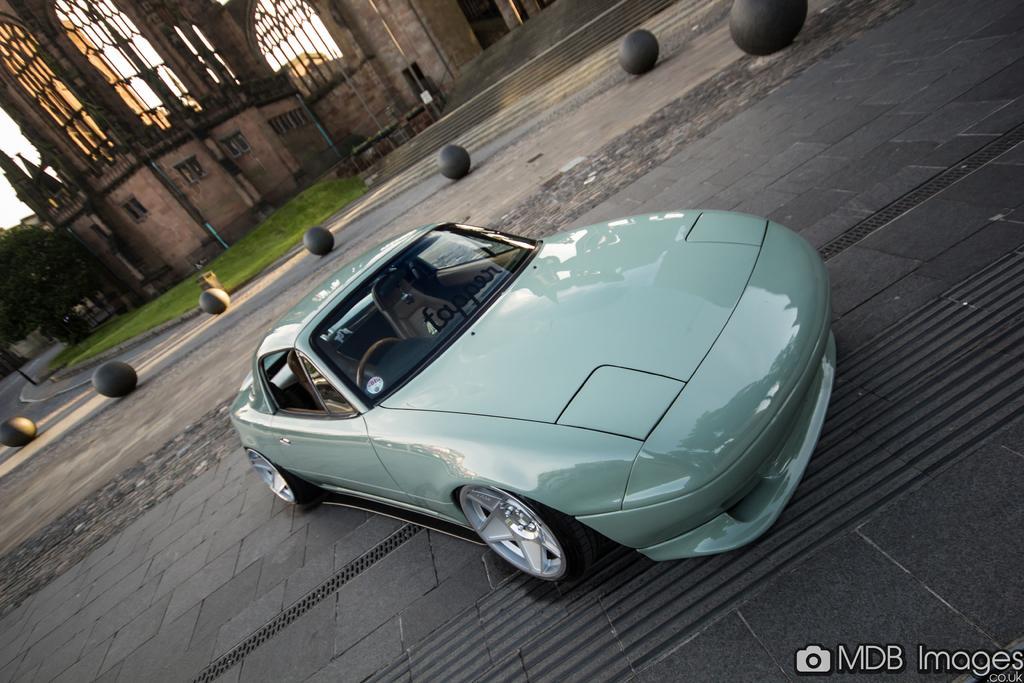Please provide a concise description of this image. In this image we can see a car on a pathway. we can also see some balls, dustbin and a tree. On the backside we can see a building with windows, stairs, poles and a board. 